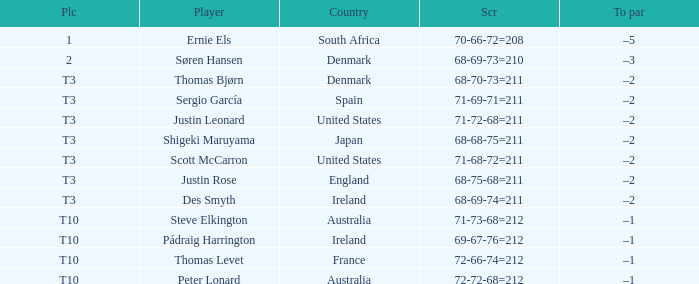What was the place when the score was 71-69-71=211? T3. 